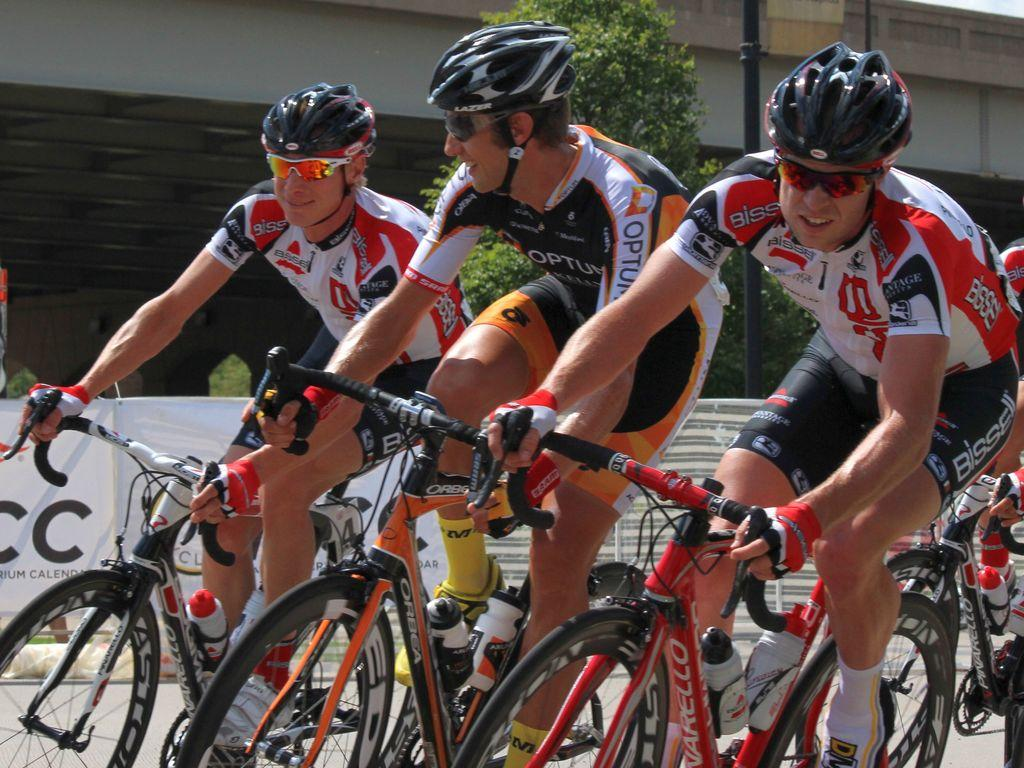How many people are in the image? There are four persons in the image. What are the persons wearing? The persons are wearing different color dresses. What activity are the persons engaged in? The persons are cycling on the road. What can be seen in the background of the image? There are banners, a tree, a pole, and a building in the background of the image. What month is it in the image? The month cannot be determined from the image, as there is no information about the time of year or any seasonal indicators present. What does the tongue of the person in the blue dress taste like? There is no information about the taste of anyone's tongue in the image, as it does not show any close-up shots of people's mouths or faces. 